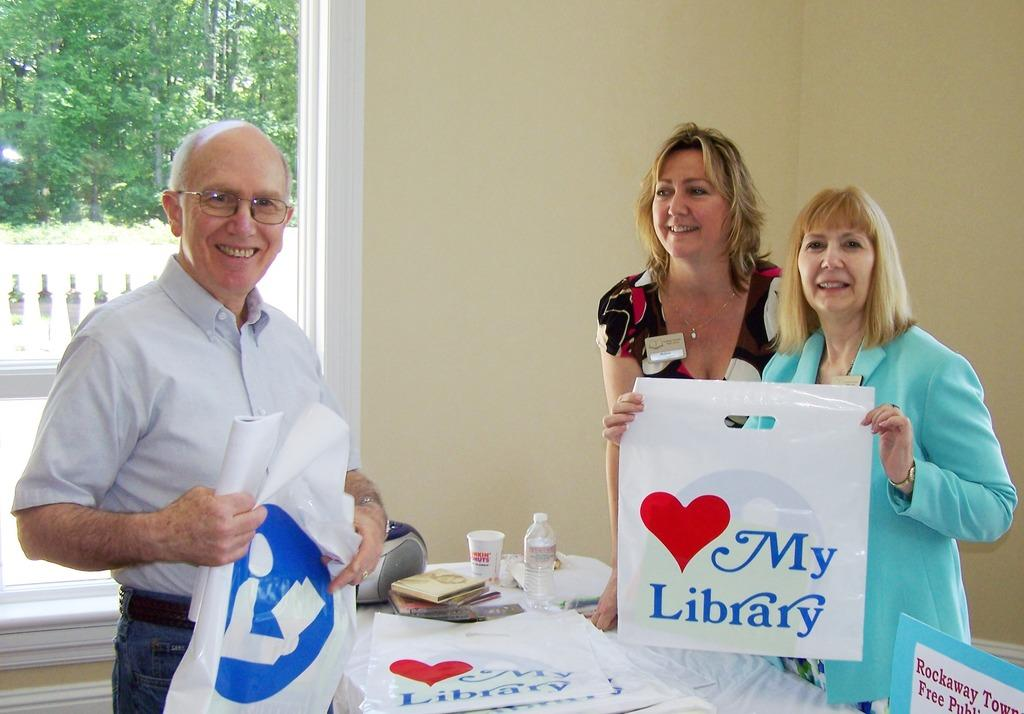<image>
Render a clear and concise summary of the photo. Two woman holding a bag that says love my library 